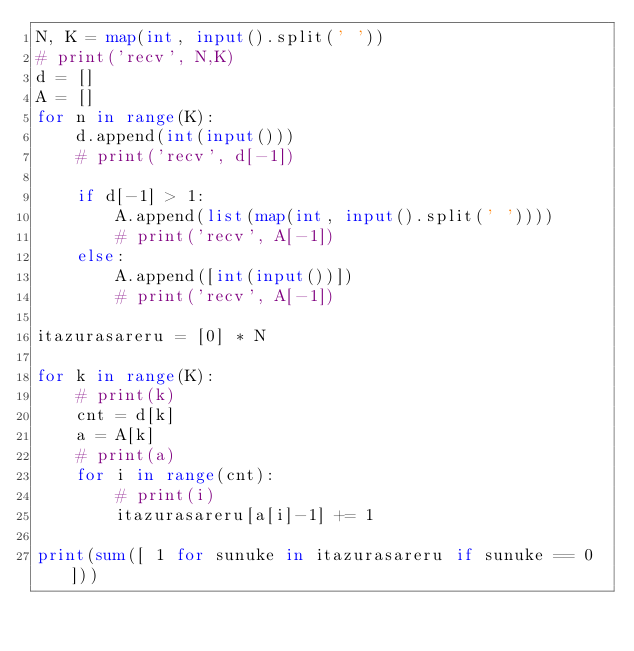<code> <loc_0><loc_0><loc_500><loc_500><_Python_>N, K = map(int, input().split(' '))
# print('recv', N,K)
d = []
A = []
for n in range(K):
    d.append(int(input()))
    # print('recv', d[-1])

    if d[-1] > 1:
        A.append(list(map(int, input().split(' '))))
        # print('recv', A[-1])
    else:
        A.append([int(input())])
        # print('recv', A[-1])

itazurasareru = [0] * N

for k in range(K):
    # print(k)
    cnt = d[k]
    a = A[k]
    # print(a)
    for i in range(cnt):
        # print(i)
        itazurasareru[a[i]-1] += 1

print(sum([ 1 for sunuke in itazurasareru if sunuke == 0 ]))
</code> 